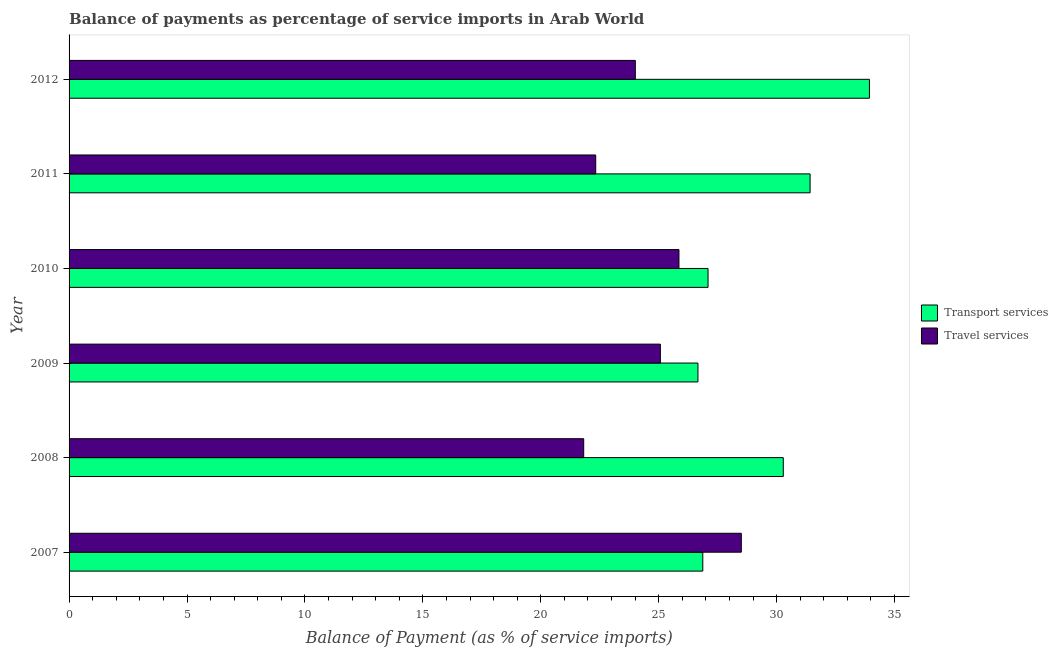Are the number of bars per tick equal to the number of legend labels?
Offer a terse response. Yes. How many bars are there on the 5th tick from the top?
Your answer should be compact. 2. How many bars are there on the 5th tick from the bottom?
Your answer should be compact. 2. What is the balance of payments of travel services in 2011?
Your answer should be very brief. 22.33. Across all years, what is the maximum balance of payments of travel services?
Offer a terse response. 28.5. Across all years, what is the minimum balance of payments of transport services?
Offer a terse response. 26.66. What is the total balance of payments of transport services in the graph?
Provide a succinct answer. 176.26. What is the difference between the balance of payments of travel services in 2010 and that in 2012?
Provide a short and direct response. 1.85. What is the difference between the balance of payments of travel services in 2011 and the balance of payments of transport services in 2007?
Your answer should be very brief. -4.54. What is the average balance of payments of transport services per year?
Offer a very short reply. 29.38. In the year 2011, what is the difference between the balance of payments of travel services and balance of payments of transport services?
Make the answer very short. -9.09. In how many years, is the balance of payments of transport services greater than 27 %?
Keep it short and to the point. 4. What is the ratio of the balance of payments of travel services in 2008 to that in 2010?
Give a very brief answer. 0.84. What is the difference between the highest and the second highest balance of payments of travel services?
Offer a very short reply. 2.65. What is the difference between the highest and the lowest balance of payments of travel services?
Keep it short and to the point. 6.68. In how many years, is the balance of payments of travel services greater than the average balance of payments of travel services taken over all years?
Offer a terse response. 3. Is the sum of the balance of payments of transport services in 2009 and 2010 greater than the maximum balance of payments of travel services across all years?
Offer a terse response. Yes. What does the 1st bar from the top in 2009 represents?
Your answer should be compact. Travel services. What does the 1st bar from the bottom in 2010 represents?
Offer a terse response. Transport services. Are all the bars in the graph horizontal?
Offer a terse response. Yes. How many years are there in the graph?
Ensure brevity in your answer.  6. Where does the legend appear in the graph?
Provide a succinct answer. Center right. How many legend labels are there?
Offer a terse response. 2. How are the legend labels stacked?
Offer a terse response. Vertical. What is the title of the graph?
Provide a short and direct response. Balance of payments as percentage of service imports in Arab World. What is the label or title of the X-axis?
Your answer should be compact. Balance of Payment (as % of service imports). What is the label or title of the Y-axis?
Provide a succinct answer. Year. What is the Balance of Payment (as % of service imports) of Transport services in 2007?
Offer a terse response. 26.87. What is the Balance of Payment (as % of service imports) of Travel services in 2007?
Keep it short and to the point. 28.5. What is the Balance of Payment (as % of service imports) in Transport services in 2008?
Your answer should be compact. 30.28. What is the Balance of Payment (as % of service imports) of Travel services in 2008?
Provide a succinct answer. 21.82. What is the Balance of Payment (as % of service imports) of Transport services in 2009?
Make the answer very short. 26.66. What is the Balance of Payment (as % of service imports) in Travel services in 2009?
Your answer should be very brief. 25.07. What is the Balance of Payment (as % of service imports) in Transport services in 2010?
Your answer should be compact. 27.09. What is the Balance of Payment (as % of service imports) of Travel services in 2010?
Your answer should be compact. 25.86. What is the Balance of Payment (as % of service imports) in Transport services in 2011?
Your answer should be compact. 31.42. What is the Balance of Payment (as % of service imports) of Travel services in 2011?
Offer a very short reply. 22.33. What is the Balance of Payment (as % of service imports) in Transport services in 2012?
Offer a very short reply. 33.94. What is the Balance of Payment (as % of service imports) of Travel services in 2012?
Give a very brief answer. 24.01. Across all years, what is the maximum Balance of Payment (as % of service imports) in Transport services?
Your answer should be compact. 33.94. Across all years, what is the maximum Balance of Payment (as % of service imports) of Travel services?
Make the answer very short. 28.5. Across all years, what is the minimum Balance of Payment (as % of service imports) in Transport services?
Offer a very short reply. 26.66. Across all years, what is the minimum Balance of Payment (as % of service imports) in Travel services?
Provide a succinct answer. 21.82. What is the total Balance of Payment (as % of service imports) in Transport services in the graph?
Your answer should be very brief. 176.26. What is the total Balance of Payment (as % of service imports) of Travel services in the graph?
Your answer should be very brief. 147.59. What is the difference between the Balance of Payment (as % of service imports) in Transport services in 2007 and that in 2008?
Your answer should be compact. -3.41. What is the difference between the Balance of Payment (as % of service imports) in Travel services in 2007 and that in 2008?
Your response must be concise. 6.68. What is the difference between the Balance of Payment (as % of service imports) of Transport services in 2007 and that in 2009?
Keep it short and to the point. 0.21. What is the difference between the Balance of Payment (as % of service imports) in Travel services in 2007 and that in 2009?
Give a very brief answer. 3.43. What is the difference between the Balance of Payment (as % of service imports) of Transport services in 2007 and that in 2010?
Offer a very short reply. -0.22. What is the difference between the Balance of Payment (as % of service imports) of Travel services in 2007 and that in 2010?
Your response must be concise. 2.64. What is the difference between the Balance of Payment (as % of service imports) of Transport services in 2007 and that in 2011?
Provide a succinct answer. -4.55. What is the difference between the Balance of Payment (as % of service imports) in Travel services in 2007 and that in 2011?
Your response must be concise. 6.17. What is the difference between the Balance of Payment (as % of service imports) in Transport services in 2007 and that in 2012?
Keep it short and to the point. -7.07. What is the difference between the Balance of Payment (as % of service imports) of Travel services in 2007 and that in 2012?
Make the answer very short. 4.5. What is the difference between the Balance of Payment (as % of service imports) in Transport services in 2008 and that in 2009?
Ensure brevity in your answer.  3.62. What is the difference between the Balance of Payment (as % of service imports) in Travel services in 2008 and that in 2009?
Keep it short and to the point. -3.25. What is the difference between the Balance of Payment (as % of service imports) in Transport services in 2008 and that in 2010?
Make the answer very short. 3.19. What is the difference between the Balance of Payment (as % of service imports) in Travel services in 2008 and that in 2010?
Provide a short and direct response. -4.04. What is the difference between the Balance of Payment (as % of service imports) of Transport services in 2008 and that in 2011?
Offer a very short reply. -1.14. What is the difference between the Balance of Payment (as % of service imports) in Travel services in 2008 and that in 2011?
Provide a short and direct response. -0.51. What is the difference between the Balance of Payment (as % of service imports) of Transport services in 2008 and that in 2012?
Make the answer very short. -3.65. What is the difference between the Balance of Payment (as % of service imports) of Travel services in 2008 and that in 2012?
Offer a terse response. -2.19. What is the difference between the Balance of Payment (as % of service imports) in Transport services in 2009 and that in 2010?
Provide a succinct answer. -0.43. What is the difference between the Balance of Payment (as % of service imports) in Travel services in 2009 and that in 2010?
Give a very brief answer. -0.79. What is the difference between the Balance of Payment (as % of service imports) in Transport services in 2009 and that in 2011?
Your answer should be very brief. -4.75. What is the difference between the Balance of Payment (as % of service imports) in Travel services in 2009 and that in 2011?
Keep it short and to the point. 2.74. What is the difference between the Balance of Payment (as % of service imports) of Transport services in 2009 and that in 2012?
Your answer should be very brief. -7.27. What is the difference between the Balance of Payment (as % of service imports) in Travel services in 2009 and that in 2012?
Offer a very short reply. 1.06. What is the difference between the Balance of Payment (as % of service imports) in Transport services in 2010 and that in 2011?
Offer a terse response. -4.33. What is the difference between the Balance of Payment (as % of service imports) in Travel services in 2010 and that in 2011?
Your answer should be compact. 3.53. What is the difference between the Balance of Payment (as % of service imports) of Transport services in 2010 and that in 2012?
Your answer should be compact. -6.84. What is the difference between the Balance of Payment (as % of service imports) in Travel services in 2010 and that in 2012?
Your response must be concise. 1.85. What is the difference between the Balance of Payment (as % of service imports) of Transport services in 2011 and that in 2012?
Make the answer very short. -2.52. What is the difference between the Balance of Payment (as % of service imports) in Travel services in 2011 and that in 2012?
Give a very brief answer. -1.68. What is the difference between the Balance of Payment (as % of service imports) in Transport services in 2007 and the Balance of Payment (as % of service imports) in Travel services in 2008?
Your response must be concise. 5.05. What is the difference between the Balance of Payment (as % of service imports) in Transport services in 2007 and the Balance of Payment (as % of service imports) in Travel services in 2009?
Make the answer very short. 1.8. What is the difference between the Balance of Payment (as % of service imports) in Transport services in 2007 and the Balance of Payment (as % of service imports) in Travel services in 2010?
Provide a short and direct response. 1.01. What is the difference between the Balance of Payment (as % of service imports) in Transport services in 2007 and the Balance of Payment (as % of service imports) in Travel services in 2011?
Keep it short and to the point. 4.54. What is the difference between the Balance of Payment (as % of service imports) in Transport services in 2007 and the Balance of Payment (as % of service imports) in Travel services in 2012?
Keep it short and to the point. 2.86. What is the difference between the Balance of Payment (as % of service imports) of Transport services in 2008 and the Balance of Payment (as % of service imports) of Travel services in 2009?
Make the answer very short. 5.21. What is the difference between the Balance of Payment (as % of service imports) of Transport services in 2008 and the Balance of Payment (as % of service imports) of Travel services in 2010?
Provide a succinct answer. 4.42. What is the difference between the Balance of Payment (as % of service imports) in Transport services in 2008 and the Balance of Payment (as % of service imports) in Travel services in 2011?
Give a very brief answer. 7.95. What is the difference between the Balance of Payment (as % of service imports) in Transport services in 2008 and the Balance of Payment (as % of service imports) in Travel services in 2012?
Make the answer very short. 6.27. What is the difference between the Balance of Payment (as % of service imports) of Transport services in 2009 and the Balance of Payment (as % of service imports) of Travel services in 2010?
Your answer should be compact. 0.81. What is the difference between the Balance of Payment (as % of service imports) of Transport services in 2009 and the Balance of Payment (as % of service imports) of Travel services in 2011?
Provide a short and direct response. 4.33. What is the difference between the Balance of Payment (as % of service imports) in Transport services in 2009 and the Balance of Payment (as % of service imports) in Travel services in 2012?
Provide a succinct answer. 2.66. What is the difference between the Balance of Payment (as % of service imports) in Transport services in 2010 and the Balance of Payment (as % of service imports) in Travel services in 2011?
Your answer should be compact. 4.76. What is the difference between the Balance of Payment (as % of service imports) of Transport services in 2010 and the Balance of Payment (as % of service imports) of Travel services in 2012?
Offer a very short reply. 3.08. What is the difference between the Balance of Payment (as % of service imports) of Transport services in 2011 and the Balance of Payment (as % of service imports) of Travel services in 2012?
Your answer should be compact. 7.41. What is the average Balance of Payment (as % of service imports) of Transport services per year?
Your response must be concise. 29.38. What is the average Balance of Payment (as % of service imports) of Travel services per year?
Offer a very short reply. 24.6. In the year 2007, what is the difference between the Balance of Payment (as % of service imports) of Transport services and Balance of Payment (as % of service imports) of Travel services?
Make the answer very short. -1.63. In the year 2008, what is the difference between the Balance of Payment (as % of service imports) of Transport services and Balance of Payment (as % of service imports) of Travel services?
Keep it short and to the point. 8.46. In the year 2009, what is the difference between the Balance of Payment (as % of service imports) in Transport services and Balance of Payment (as % of service imports) in Travel services?
Provide a short and direct response. 1.59. In the year 2010, what is the difference between the Balance of Payment (as % of service imports) in Transport services and Balance of Payment (as % of service imports) in Travel services?
Offer a very short reply. 1.23. In the year 2011, what is the difference between the Balance of Payment (as % of service imports) in Transport services and Balance of Payment (as % of service imports) in Travel services?
Your answer should be very brief. 9.09. In the year 2012, what is the difference between the Balance of Payment (as % of service imports) of Transport services and Balance of Payment (as % of service imports) of Travel services?
Ensure brevity in your answer.  9.93. What is the ratio of the Balance of Payment (as % of service imports) in Transport services in 2007 to that in 2008?
Your answer should be compact. 0.89. What is the ratio of the Balance of Payment (as % of service imports) of Travel services in 2007 to that in 2008?
Provide a short and direct response. 1.31. What is the ratio of the Balance of Payment (as % of service imports) in Transport services in 2007 to that in 2009?
Your answer should be compact. 1.01. What is the ratio of the Balance of Payment (as % of service imports) of Travel services in 2007 to that in 2009?
Provide a short and direct response. 1.14. What is the ratio of the Balance of Payment (as % of service imports) of Travel services in 2007 to that in 2010?
Your answer should be compact. 1.1. What is the ratio of the Balance of Payment (as % of service imports) of Transport services in 2007 to that in 2011?
Your response must be concise. 0.86. What is the ratio of the Balance of Payment (as % of service imports) in Travel services in 2007 to that in 2011?
Your response must be concise. 1.28. What is the ratio of the Balance of Payment (as % of service imports) of Transport services in 2007 to that in 2012?
Offer a very short reply. 0.79. What is the ratio of the Balance of Payment (as % of service imports) of Travel services in 2007 to that in 2012?
Make the answer very short. 1.19. What is the ratio of the Balance of Payment (as % of service imports) of Transport services in 2008 to that in 2009?
Your response must be concise. 1.14. What is the ratio of the Balance of Payment (as % of service imports) of Travel services in 2008 to that in 2009?
Offer a terse response. 0.87. What is the ratio of the Balance of Payment (as % of service imports) in Transport services in 2008 to that in 2010?
Your response must be concise. 1.12. What is the ratio of the Balance of Payment (as % of service imports) of Travel services in 2008 to that in 2010?
Your response must be concise. 0.84. What is the ratio of the Balance of Payment (as % of service imports) in Transport services in 2008 to that in 2011?
Keep it short and to the point. 0.96. What is the ratio of the Balance of Payment (as % of service imports) of Travel services in 2008 to that in 2011?
Make the answer very short. 0.98. What is the ratio of the Balance of Payment (as % of service imports) of Transport services in 2008 to that in 2012?
Give a very brief answer. 0.89. What is the ratio of the Balance of Payment (as % of service imports) of Travel services in 2008 to that in 2012?
Offer a very short reply. 0.91. What is the ratio of the Balance of Payment (as % of service imports) in Transport services in 2009 to that in 2010?
Offer a terse response. 0.98. What is the ratio of the Balance of Payment (as % of service imports) in Travel services in 2009 to that in 2010?
Offer a very short reply. 0.97. What is the ratio of the Balance of Payment (as % of service imports) in Transport services in 2009 to that in 2011?
Give a very brief answer. 0.85. What is the ratio of the Balance of Payment (as % of service imports) in Travel services in 2009 to that in 2011?
Make the answer very short. 1.12. What is the ratio of the Balance of Payment (as % of service imports) in Transport services in 2009 to that in 2012?
Keep it short and to the point. 0.79. What is the ratio of the Balance of Payment (as % of service imports) in Travel services in 2009 to that in 2012?
Ensure brevity in your answer.  1.04. What is the ratio of the Balance of Payment (as % of service imports) in Transport services in 2010 to that in 2011?
Offer a very short reply. 0.86. What is the ratio of the Balance of Payment (as % of service imports) in Travel services in 2010 to that in 2011?
Your answer should be very brief. 1.16. What is the ratio of the Balance of Payment (as % of service imports) in Transport services in 2010 to that in 2012?
Provide a short and direct response. 0.8. What is the ratio of the Balance of Payment (as % of service imports) in Travel services in 2010 to that in 2012?
Offer a terse response. 1.08. What is the ratio of the Balance of Payment (as % of service imports) of Transport services in 2011 to that in 2012?
Keep it short and to the point. 0.93. What is the ratio of the Balance of Payment (as % of service imports) in Travel services in 2011 to that in 2012?
Your response must be concise. 0.93. What is the difference between the highest and the second highest Balance of Payment (as % of service imports) of Transport services?
Your answer should be compact. 2.52. What is the difference between the highest and the second highest Balance of Payment (as % of service imports) of Travel services?
Give a very brief answer. 2.64. What is the difference between the highest and the lowest Balance of Payment (as % of service imports) in Transport services?
Offer a terse response. 7.27. What is the difference between the highest and the lowest Balance of Payment (as % of service imports) in Travel services?
Ensure brevity in your answer.  6.68. 